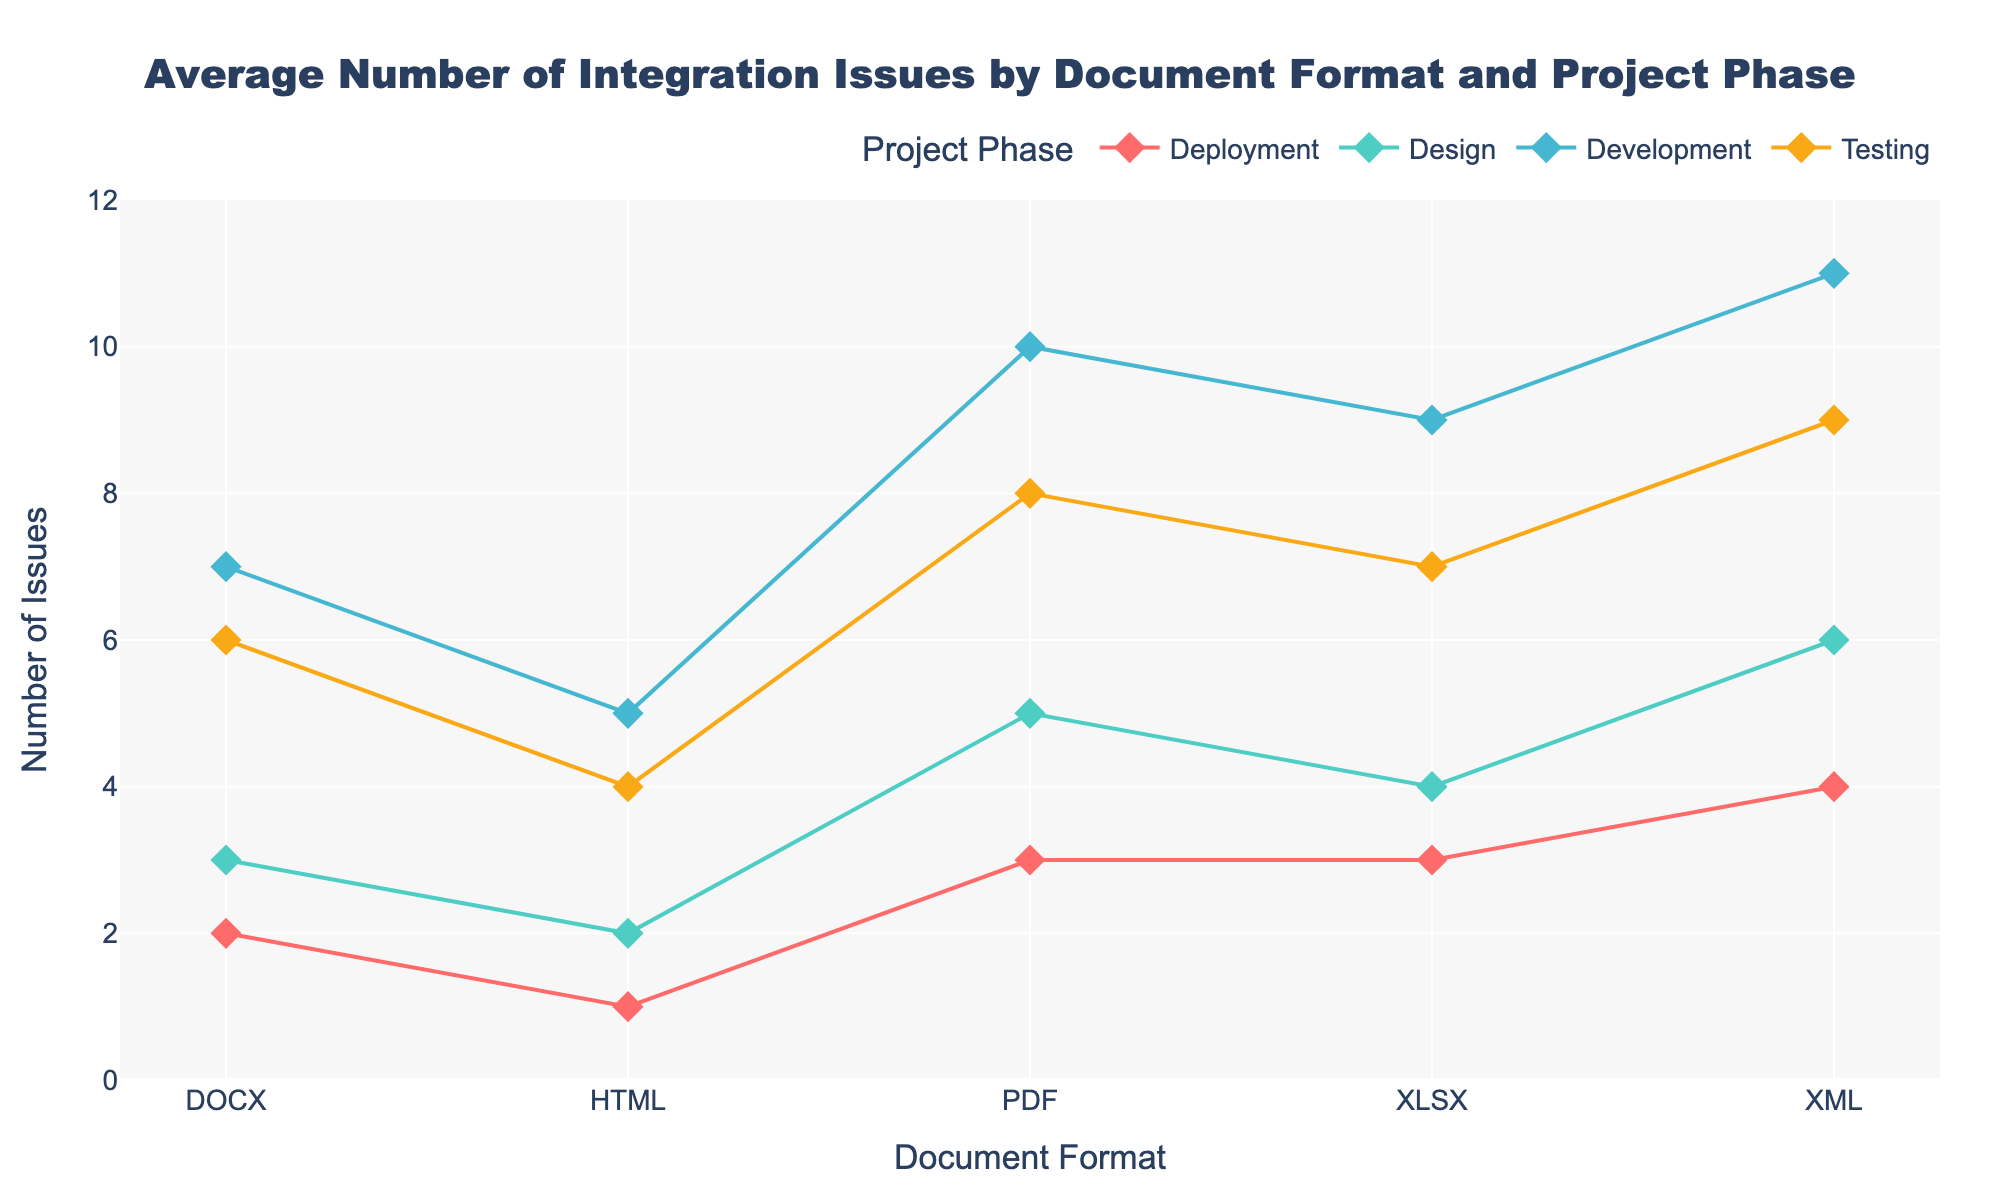What's the title of the plot? The title is located at the top of the plot. By reading it, we can determine the exact name given to the visual representation.
Answer: Average Number of Integration Issues by Document Format and Project Phase Which document format has the most issues during the deployment phase? By looking at the Deployment phase markers, we compare the y-values across different document formats to find the highest point.
Answer: XML What is the average number of issues encountered in the testing phase for all document formats? Sum the number of issues in the Testing phase for each document format (5+6+7+4+9), and then divide by the number of document formats (5). So, (5+6+7+4+9)/5 = 6.2
Answer: 6.2 Which project phase has the highest number of issues for the HTML document format? By examining the markers for HTML across all phases, we can determine which phase has the highest y-value marker.
Answer: Development How many more issues are encountered with PDF compared to DOCX during the development phase? Find the number of issues for PDF (10) and DOCX (7) during development and subtract the smaller number from the larger: 10 - 7.
Answer: 3 What's the range of issues encountered in the XML format across all phases? Identify the smallest and largest number of issues for XML across all phases (6 to 11), then subtract the smallest from the largest: 11 - 6.
Answer: 5 Which document format shows the least variation in the number of issues across different project phases? Calculate the range (difference between max and min values) of issues for each document format and determine the smallest value. PDF: 10-3=7, DOCX: 7-2=5, XLSX: 9-3=6, HTML: 5-1=4, XML: 11-4=7.
Answer: HTML What is the sum of issues encountered in the design phase across all document formats? Sum the number of issues for Design phase across all document formats: 5 (PDF) + 3 (DOCX) + 4 (XLSX) + 2 (HTML) + 6 (XML). So, 5 + 3 + 4 + 2 + 6 = 20
Answer: 20 How does the average number of issues in the Development phase compare to the average in the Deployment phase? Compute the average number of issues in Development: (10+7+9+5+11)/5 = 8.4. Compute the average in Deployment: (3+2+3+1+4)/5 = 2.6. Compare 8.4 and 2.6.
Answer: The average in Development is higher Which document format experienced the highest total number of issues across all phases? Sum the issues across all phases for each document format and compare the totals: PDF: 5+10+8+3, DOCX: 3+7+6+2, XLSX: 4+9+7+3, HTML: 2+5+4+1, XML: 6+11+9+4.
Answer: XML 